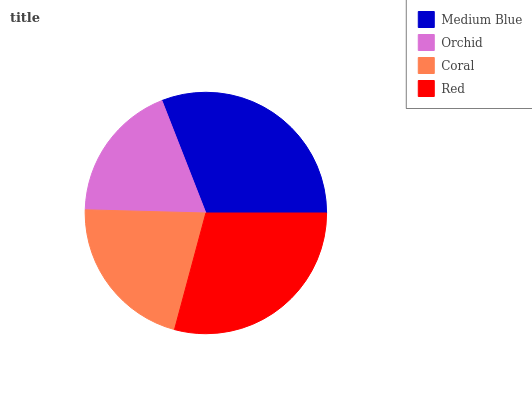Is Orchid the minimum?
Answer yes or no. Yes. Is Medium Blue the maximum?
Answer yes or no. Yes. Is Coral the minimum?
Answer yes or no. No. Is Coral the maximum?
Answer yes or no. No. Is Coral greater than Orchid?
Answer yes or no. Yes. Is Orchid less than Coral?
Answer yes or no. Yes. Is Orchid greater than Coral?
Answer yes or no. No. Is Coral less than Orchid?
Answer yes or no. No. Is Red the high median?
Answer yes or no. Yes. Is Coral the low median?
Answer yes or no. Yes. Is Medium Blue the high median?
Answer yes or no. No. Is Medium Blue the low median?
Answer yes or no. No. 